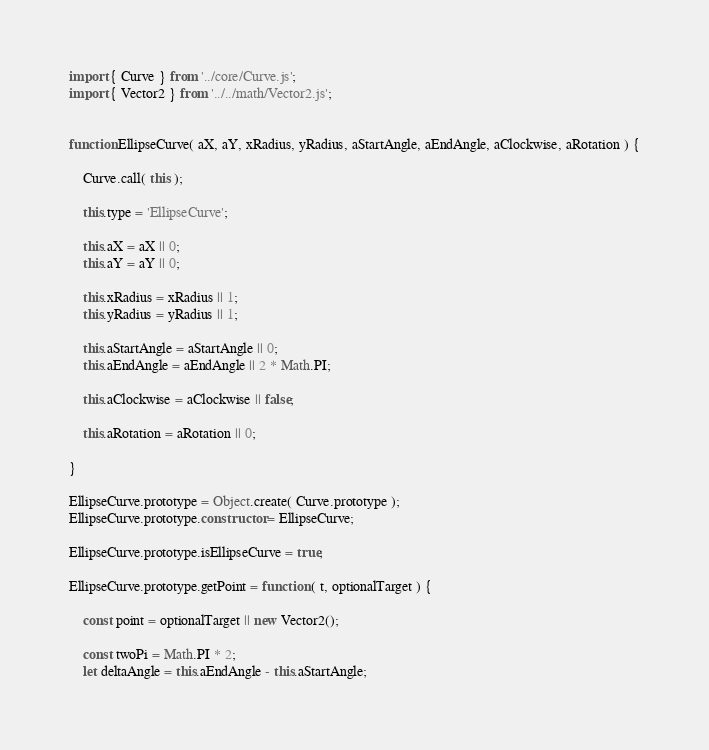Convert code to text. <code><loc_0><loc_0><loc_500><loc_500><_JavaScript_>import { Curve } from '../core/Curve.js';
import { Vector2 } from '../../math/Vector2.js';


function EllipseCurve( aX, aY, xRadius, yRadius, aStartAngle, aEndAngle, aClockwise, aRotation ) {

	Curve.call( this );

	this.type = 'EllipseCurve';

	this.aX = aX || 0;
	this.aY = aY || 0;

	this.xRadius = xRadius || 1;
	this.yRadius = yRadius || 1;

	this.aStartAngle = aStartAngle || 0;
	this.aEndAngle = aEndAngle || 2 * Math.PI;

	this.aClockwise = aClockwise || false;

	this.aRotation = aRotation || 0;

}

EllipseCurve.prototype = Object.create( Curve.prototype );
EllipseCurve.prototype.constructor = EllipseCurve;

EllipseCurve.prototype.isEllipseCurve = true;

EllipseCurve.prototype.getPoint = function ( t, optionalTarget ) {

	const point = optionalTarget || new Vector2();

	const twoPi = Math.PI * 2;
	let deltaAngle = this.aEndAngle - this.aStartAngle;</code> 